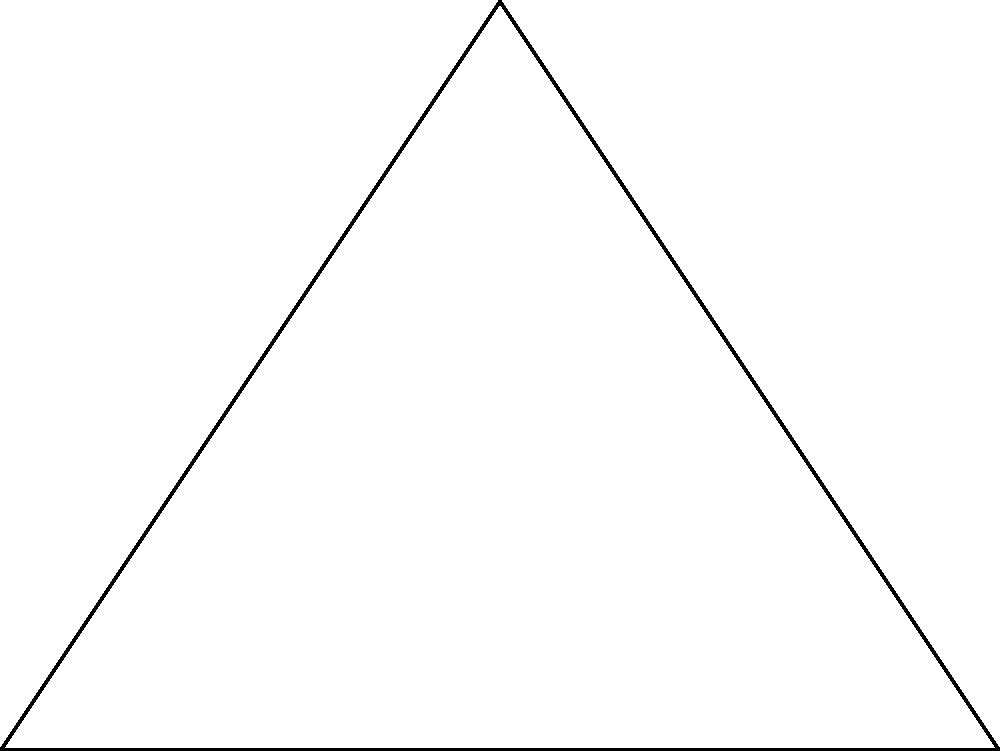In the context of somatic therapy, consider an isosceles triangle ABC representing a balanced emotional state. If the base of the triangle is 4 units long and the two equal sides are represented by $x$, what is the value of $x$ that would create a right-angled triangle at C? How might this relate to achieving emotional balance through body-based techniques? Let's approach this step-by-step:

1) In an isosceles right triangle, the two equal sides form the right angle, and the base is the hypotenuse.

2) We can use the Pythagorean theorem to solve for $x$:
   $$x^2 + x^2 = 4^2$$

3) Simplify:
   $$2x^2 = 16$$

4) Divide both sides by 2:
   $$x^2 = 8$$

5) Take the square root of both sides:
   $$x = \sqrt{8} = 2\sqrt{2}$$

6) In somatic therapy, this balanced triangle could represent:
   - The base (4 units) as the foundation or grounding in the body
   - The equal sides ($x = 2\sqrt{2}$) as balanced emotional states
   - The right angle as the integration point where body awareness meets emotional balance

7) The specific value $2\sqrt{2}$ could symbolize the ideal balance between physical grounding (represented by the whole number 2) and emotional depth (represented by the irrational number $\sqrt{2}$).

8) In practice, this geometric representation could guide body-based techniques to achieve a balanced emotional state, where grounding exercises (base) lead to equal parts of emotional release and containment (equal sides).
Answer: $x = 2\sqrt{2}$ 